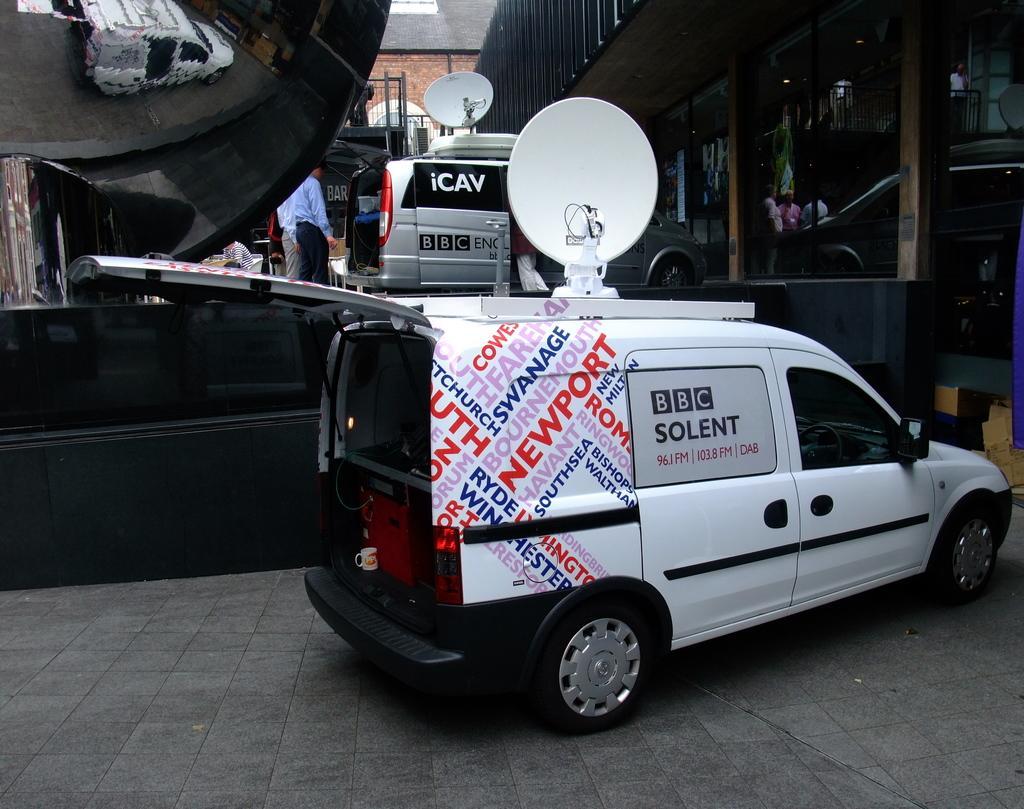Please provide a concise description of this image. In this image we can see some vehicles with dishes on it which are placed on the ground. On the backside we can see a building with windows and two men standing. 